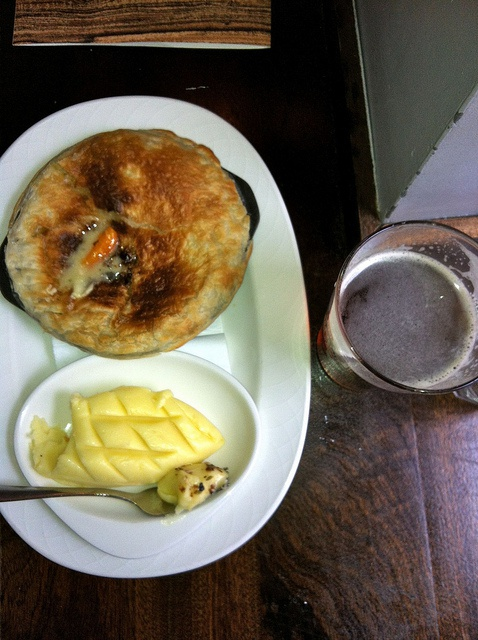Describe the objects in this image and their specific colors. I can see dining table in black, gray, lightgray, maroon, and darkgray tones, bowl in black, ivory, khaki, and tan tones, cup in black, gray, and darkgray tones, and spoon in black, olive, gray, and darkgray tones in this image. 